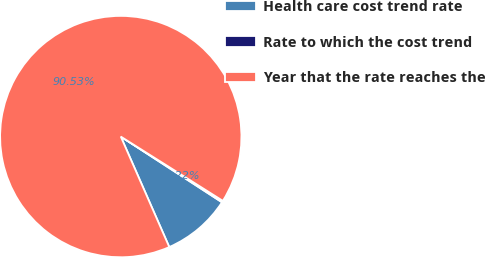Convert chart to OTSL. <chart><loc_0><loc_0><loc_500><loc_500><pie_chart><fcel>Health care cost trend rate<fcel>Rate to which the cost trend<fcel>Year that the rate reaches the<nl><fcel>9.25%<fcel>0.22%<fcel>90.52%<nl></chart> 